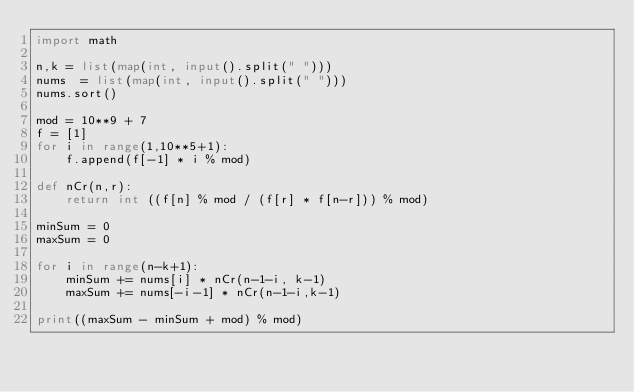Convert code to text. <code><loc_0><loc_0><loc_500><loc_500><_Python_>import math

n,k = list(map(int, input().split(" ")))
nums  = list(map(int, input().split(" ")))
nums.sort()

mod = 10**9 + 7
f = [1]
for i in range(1,10**5+1):
    f.append(f[-1] * i % mod)

def nCr(n,r):
    return int ((f[n] % mod / (f[r] * f[n-r])) % mod)

minSum = 0
maxSum = 0

for i in range(n-k+1):
    minSum += nums[i] * nCr(n-1-i, k-1)
    maxSum += nums[-i-1] * nCr(n-1-i,k-1)

print((maxSum - minSum + mod) % mod)</code> 